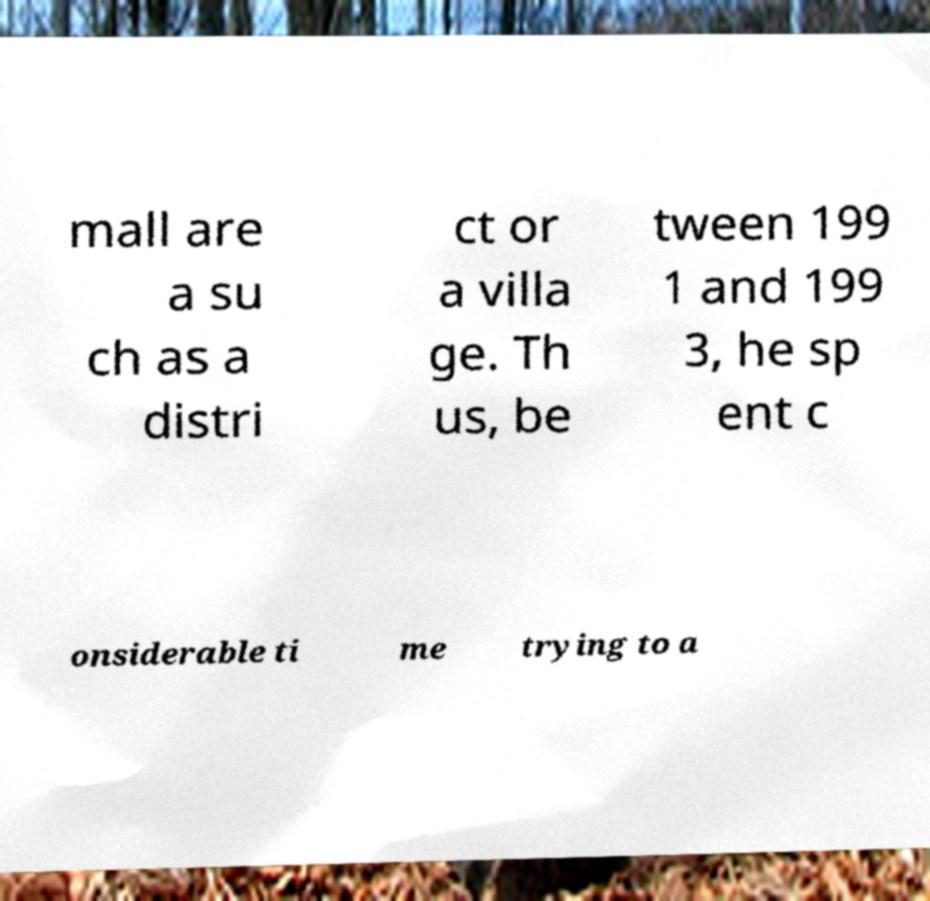Can you accurately transcribe the text from the provided image for me? mall are a su ch as a distri ct or a villa ge. Th us, be tween 199 1 and 199 3, he sp ent c onsiderable ti me trying to a 